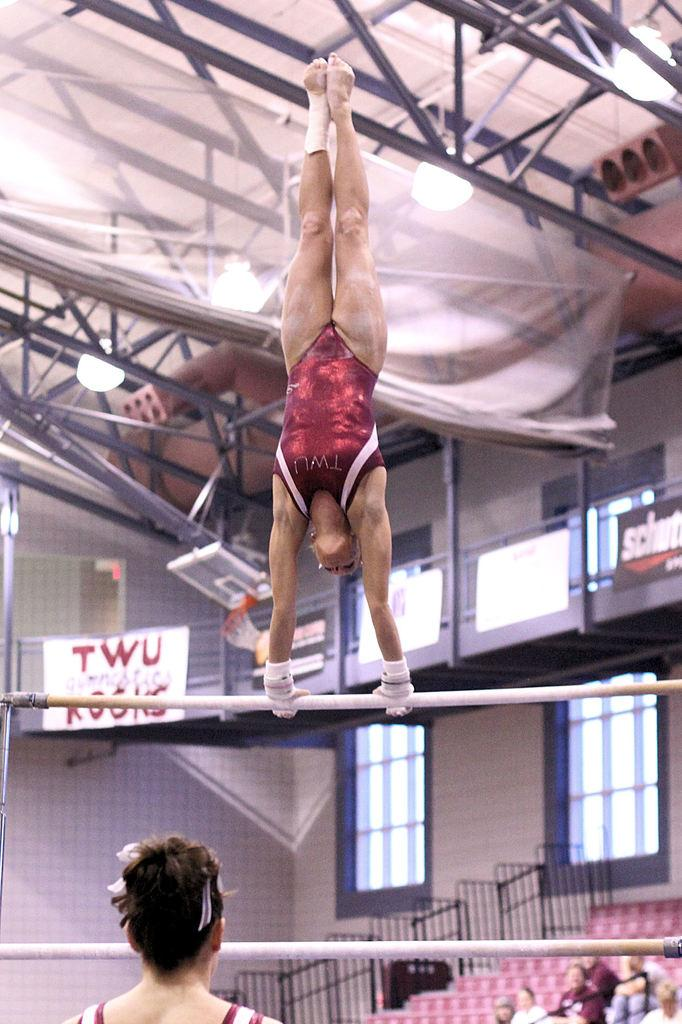<image>
Describe the image concisely. A TWU gymnast wearing a burgundy one piece is performing on the parallel bars. 